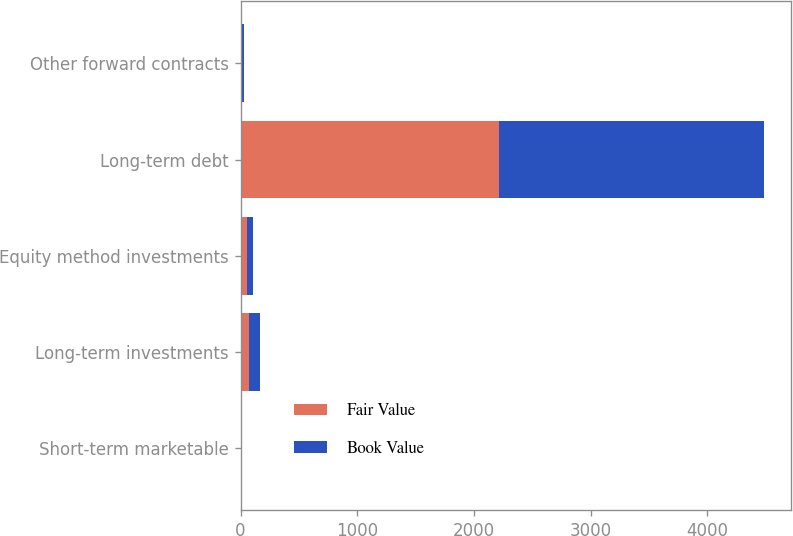Convert chart to OTSL. <chart><loc_0><loc_0><loc_500><loc_500><stacked_bar_chart><ecel><fcel>Short-term marketable<fcel>Long-term investments<fcel>Equity method investments<fcel>Long-term debt<fcel>Other forward contracts<nl><fcel>Fair Value<fcel>1.4<fcel>73<fcel>55.1<fcel>2214.4<fcel>13.7<nl><fcel>Book Value<fcel>1.4<fcel>91.2<fcel>55.1<fcel>2275.2<fcel>13.7<nl></chart> 